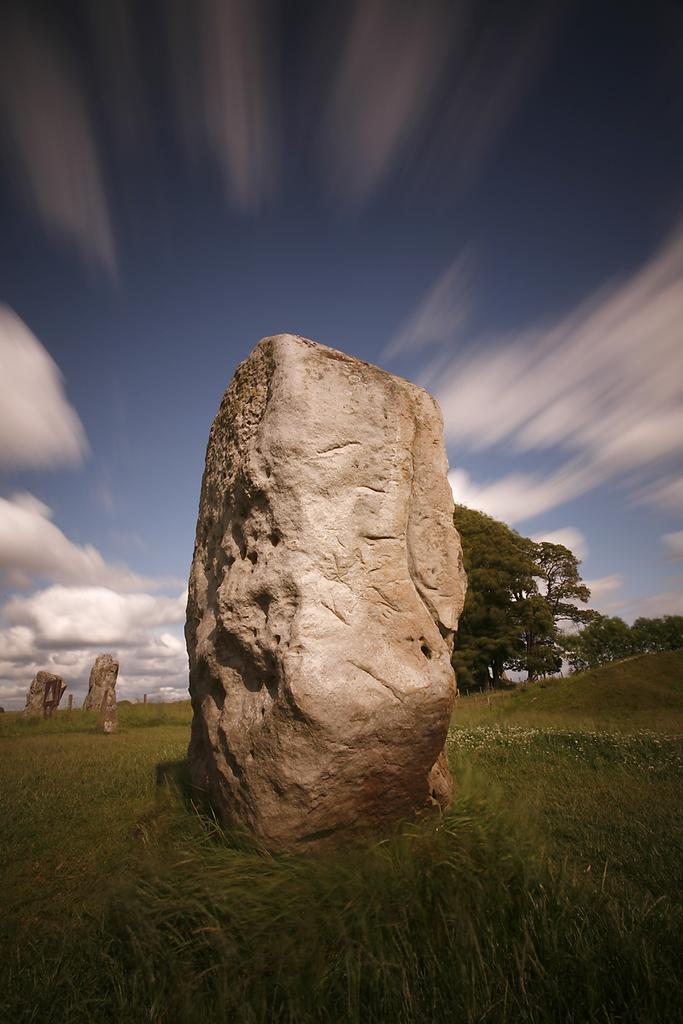What is the main object in the image? There is a stone in the image. What type of vegetation is present around the stone? Grass is present around the stone. What can be seen in the background of the image? There are trees and stones in the background of the image, as well as the sky. What type of drum can be heard playing in the fall music in the image? There is no drum or music present in the image; it features a stone with grass and trees in the background. 